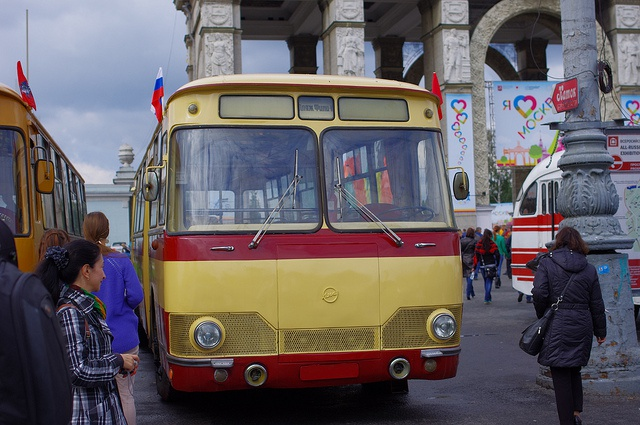Describe the objects in this image and their specific colors. I can see bus in darkgray, tan, gray, maroon, and black tones, bus in darkgray, gray, black, and maroon tones, people in darkgray, black, gray, and maroon tones, backpack in darkgray, black, purple, and maroon tones, and people in darkgray, black, gray, and navy tones in this image. 